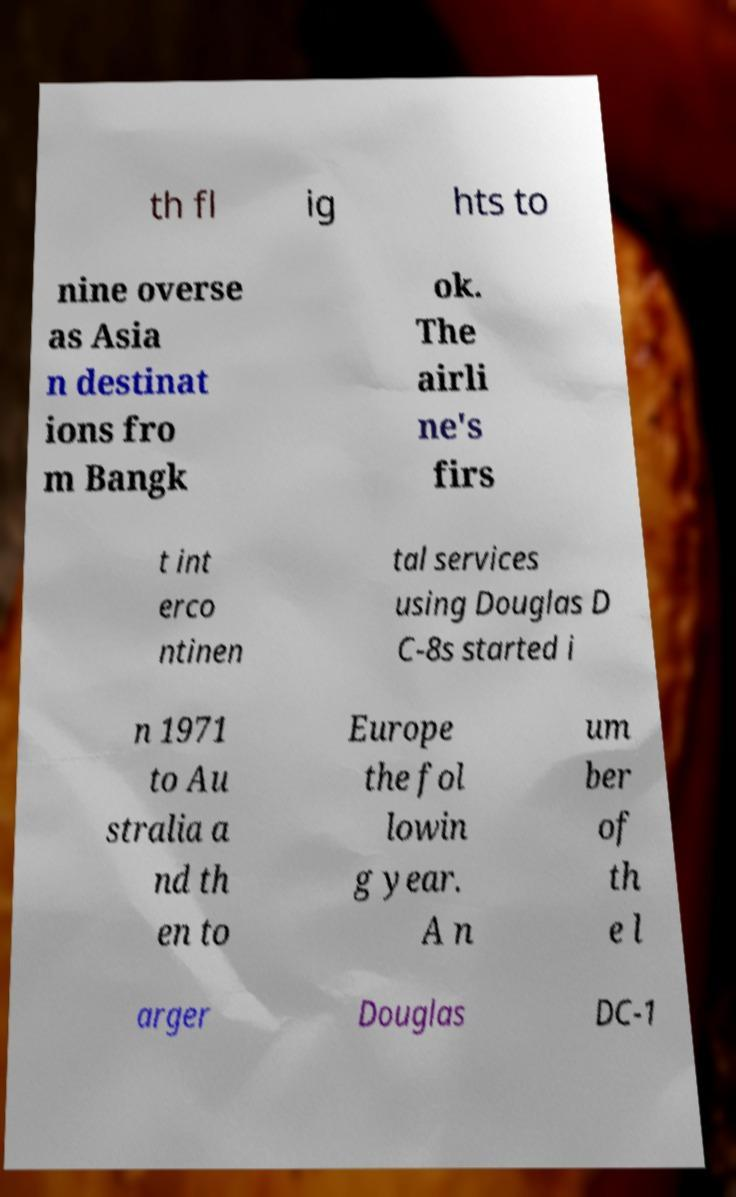Can you accurately transcribe the text from the provided image for me? th fl ig hts to nine overse as Asia n destinat ions fro m Bangk ok. The airli ne's firs t int erco ntinen tal services using Douglas D C-8s started i n 1971 to Au stralia a nd th en to Europe the fol lowin g year. A n um ber of th e l arger Douglas DC-1 